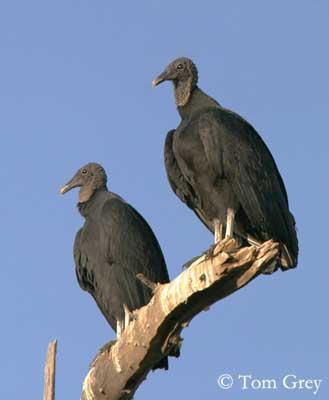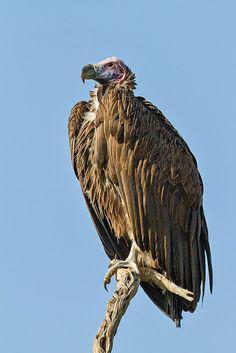The first image is the image on the left, the second image is the image on the right. Analyze the images presented: Is the assertion "There are three vultures" valid? Answer yes or no. Yes. 